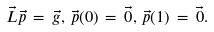<formula> <loc_0><loc_0><loc_500><loc_500>\vec { L } \vec { p } \, = \, \vec { g } , \, \vec { p } ( 0 ) \, = \, \vec { 0 } , \, \vec { p } ( 1 ) \, = \, \vec { 0 } .</formula> 